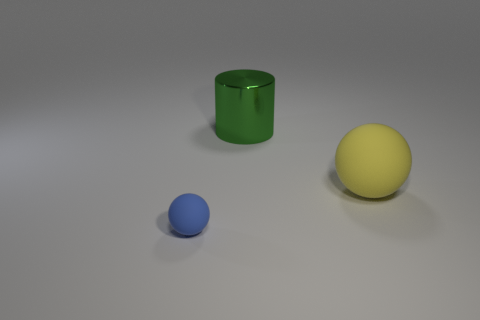What color is the tiny thing that is the same shape as the large yellow object?
Make the answer very short. Blue. Is the number of small cyan matte things less than the number of large metal cylinders?
Make the answer very short. Yes. There is a yellow object; is its size the same as the ball on the left side of the big rubber thing?
Your answer should be compact. No. The rubber object in front of the matte sphere that is right of the blue sphere is what color?
Provide a short and direct response. Blue. How many things are spheres that are in front of the large yellow object or things behind the blue object?
Offer a very short reply. 3. Is the size of the green cylinder the same as the blue matte thing?
Keep it short and to the point. No. Is there any other thing that has the same size as the blue matte ball?
Provide a succinct answer. No. There is a object in front of the yellow rubber object; is it the same shape as the large green object that is behind the big yellow matte sphere?
Offer a terse response. No. The yellow sphere is what size?
Make the answer very short. Large. What material is the sphere that is behind the sphere that is in front of the large thing that is in front of the large green cylinder made of?
Your answer should be very brief. Rubber. 